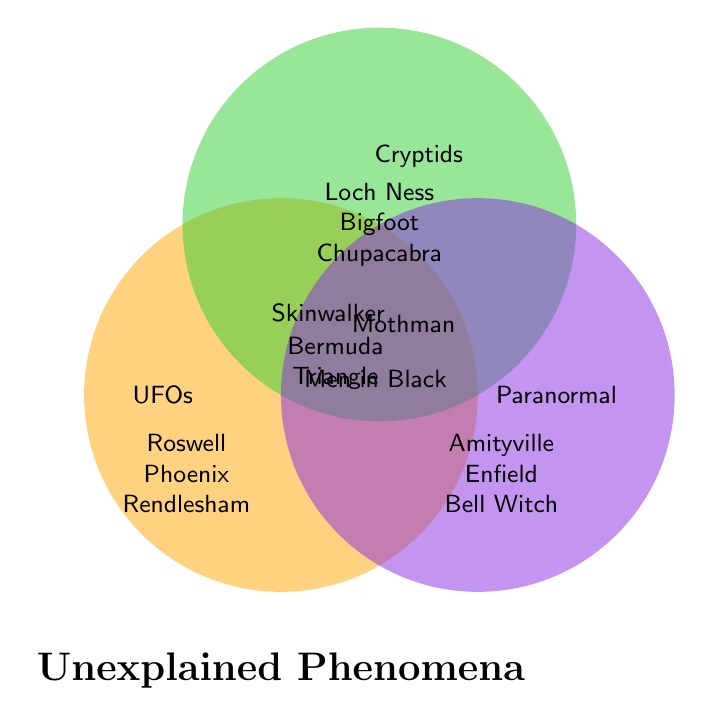Who is associated with UFO phenomena? Look at the section labeled "UFOs", which contains "Roswell Incident", "Phoenix Lights", and "Rendlesham Forest".
Answer: Roswell Incident, Phoenix Lights, Rendlesham Forest What phenomena involve both UFOs and Paranormal activities? Check the overlapping section between the "UFOs" and "Paranormal" circles which lists "Men in Black".
Answer: Men in Black Which phenomena are common to all three categories: UFOs, Cryptids, and Paranormal? Observe the center overlapping region where all three circles intersect, indicating "Bermuda Triangle".
Answer: Bermuda Triangle How many phenomena are unique to Cryptids? Count the items in the Cryptids section that do not overlap with any other category. There are "Loch Ness Monster", "Bigfoot", and "Chupacabra".
Answer: 3 Which phenomenon is exclusive to the Paranormal category? Look at the section labeled "Paranormal" without overlap that lists "Amityville Horror", "Enfield Poltergeist", and "Bell Witch".
Answer: Amityville Horror, Enfield Poltergeist, Bell Witch Compare the numbers of unique phenomena in UFOs and Cryptids categories. Which has more? Count the unique phenomena in each category: UFOs have 3, Cryptids also have 3. Both categories have the same number of unique phenomena.
Answer: Equal Identify a phenomenon involving Cryptids and Paranormal but not UFOs. Check the overlapping section between "Cryptids" and "Paranormal" circles that lists "Skinwalker Ranch".
Answer: Skinwalker Ranch How many phenomena are associated with more than one category? Add the phenomena from the overlapping regions: Mothman, Men in Black, Skinwalker Ranch, Bermuda Triangle. There are 4.
Answer: 4 Name a phenomenon related to both UFOs and Cryptids. Look at the section that intersects both the "UFOs" and "Cryptids" regions, revealing "Mothman".
Answer: Mothman 